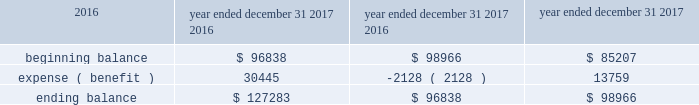Welltower inc .
Notes to consolidated financial statements is no longer present ( and additional weight may be given to subjective evidence such as our projections for growth ) .
The valuation allowance rollforward is summarized as follows for the periods presented ( in thousands ) : year ended december 31 , 2017 2016 2015 .
As a result of certain acquisitions , we are subject to corporate level taxes for any related asset dispositions that may occur during the five-year period immediately after such assets were owned by a c corporation ( 201cbuilt-in gains tax 201d ) .
The amount of income potentially subject to this special corporate level tax is generally equal to the lesser of ( a ) the excess of the fair value of the asset over its adjusted tax basis as of the date it became a reit asset , or ( b ) the actual amount of gain .
Some but not all gains recognized during this period of time could be offset by available net operating losses and capital loss carryforwards .
During the year ended december 31 , 2016 , we acquired certain additional assets with built-in gains as of the date of acquisition that could be subject to the built-in gains tax if disposed of prior to the expiration of the applicable ten-year period .
We have not recorded a deferred tax liability as a result of the potential built-in gains tax based on our intentions with respect to such properties and available tax planning strategies .
Under the provisions of the reit investment diversification and empowerment act of 2007 ( 201cridea 201d ) , for taxable years beginning after july 30 , 2008 , the reit may lease 201cqualified health care properties 201d on an arm 2019s-length basis to a trs if the property is operated on behalf of such subsidiary by a person who qualifies as an 201celigible independent contractor . 201d generally , the rent received from the trs will meet the related party rent exception and will be treated as 201crents from real property . 201d a 201cqualified health care property 201d includes real property and any personal property that is , or is necessary or incidental to the use of , a hospital , nursing facility , assisted living facility , congregate care facility , qualified continuing care facility , or other licensed facility which extends medical or nursing or ancillary services to patients .
We have entered into various joint ventures that were structured under ridea .
Resident level rents and related operating expenses for these facilities are reported in the consolidated financial statements and are subject to federal , state and foreign income taxes as the operations of such facilities are included in a trs .
Certain net operating loss carryforwards could be utilized to offset taxable income in future years .
Given the applicable statute of limitations , we generally are subject to audit by the internal revenue service ( 201cirs 201d ) for the year ended december 31 , 2014 and subsequent years .
The statute of limitations may vary in the states in which we own properties or conduct business .
We do not expect to be subject to audit by state taxing authorities for any year prior to the year ended december 31 , 2011 .
We are also subject to audit by the canada revenue agency and provincial authorities generally for periods subsequent to may 2012 related to entities acquired or formed in connection with acquisitions , and by the u.k . 2019s hm revenue & customs for periods subsequent to august 2012 related to entities acquired or formed in connection with acquisitions .
At december 31 , 2017 , we had a net operating loss ( 201cnol 201d ) carryforward related to the reit of $ 448475000 .
Due to our uncertainty regarding the realization of certain deferred tax assets , we have not recorded a deferred tax asset related to nols generated by the reit .
These amounts can be used to offset future taxable income ( and/or taxable income for prior years if an audit determines that tax is owed ) , if any .
The reit will be entitled to utilize nols and tax credit carryforwards only to the extent that reit taxable income exceeds our deduction for dividends paid .
The nol carryforwards generated through december 31 , 2017 will expire through 2036 .
Beginning with tax years after december 31 , 2017 , the tax cuts and jobs act ( 201ctax act 201d ) eliminates the carryback period , limits the nols to 80% ( 80 % ) of taxable income and replaces the 20-year carryforward period with an indefinite carryforward period. .
For the years ended december 31 2017 , 2016 , and 2015 , what was the average beginning balance in millions? 
Computations: table_average(beginning balance, none)
Answer: 93670.33333. 